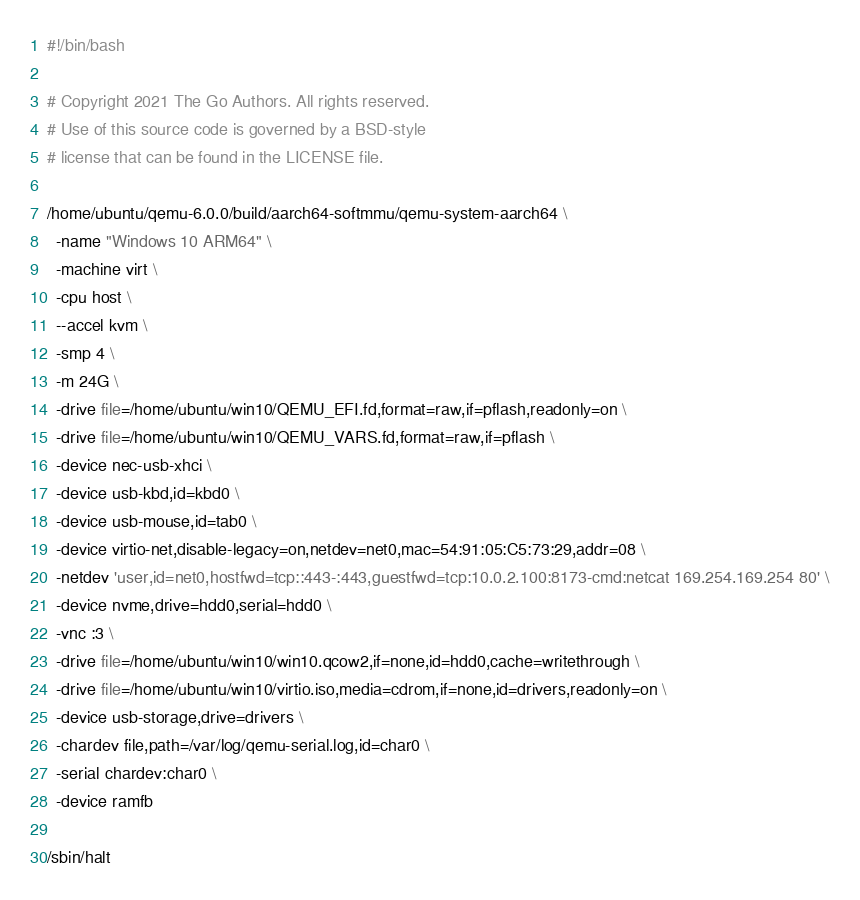<code> <loc_0><loc_0><loc_500><loc_500><_Bash_>#!/bin/bash

# Copyright 2021 The Go Authors. All rights reserved.
# Use of this source code is governed by a BSD-style
# license that can be found in the LICENSE file.

/home/ubuntu/qemu-6.0.0/build/aarch64-softmmu/qemu-system-aarch64 \
  -name "Windows 10 ARM64" \
  -machine virt \
  -cpu host \
  --accel kvm \
  -smp 4 \
  -m 24G \
  -drive file=/home/ubuntu/win10/QEMU_EFI.fd,format=raw,if=pflash,readonly=on \
  -drive file=/home/ubuntu/win10/QEMU_VARS.fd,format=raw,if=pflash \
  -device nec-usb-xhci \
  -device usb-kbd,id=kbd0 \
  -device usb-mouse,id=tab0 \
  -device virtio-net,disable-legacy=on,netdev=net0,mac=54:91:05:C5:73:29,addr=08 \
  -netdev 'user,id=net0,hostfwd=tcp::443-:443,guestfwd=tcp:10.0.2.100:8173-cmd:netcat 169.254.169.254 80' \
  -device nvme,drive=hdd0,serial=hdd0 \
  -vnc :3 \
  -drive file=/home/ubuntu/win10/win10.qcow2,if=none,id=hdd0,cache=writethrough \
  -drive file=/home/ubuntu/win10/virtio.iso,media=cdrom,if=none,id=drivers,readonly=on \
  -device usb-storage,drive=drivers \
  -chardev file,path=/var/log/qemu-serial.log,id=char0 \
  -serial chardev:char0 \
  -device ramfb

/sbin/halt
</code> 